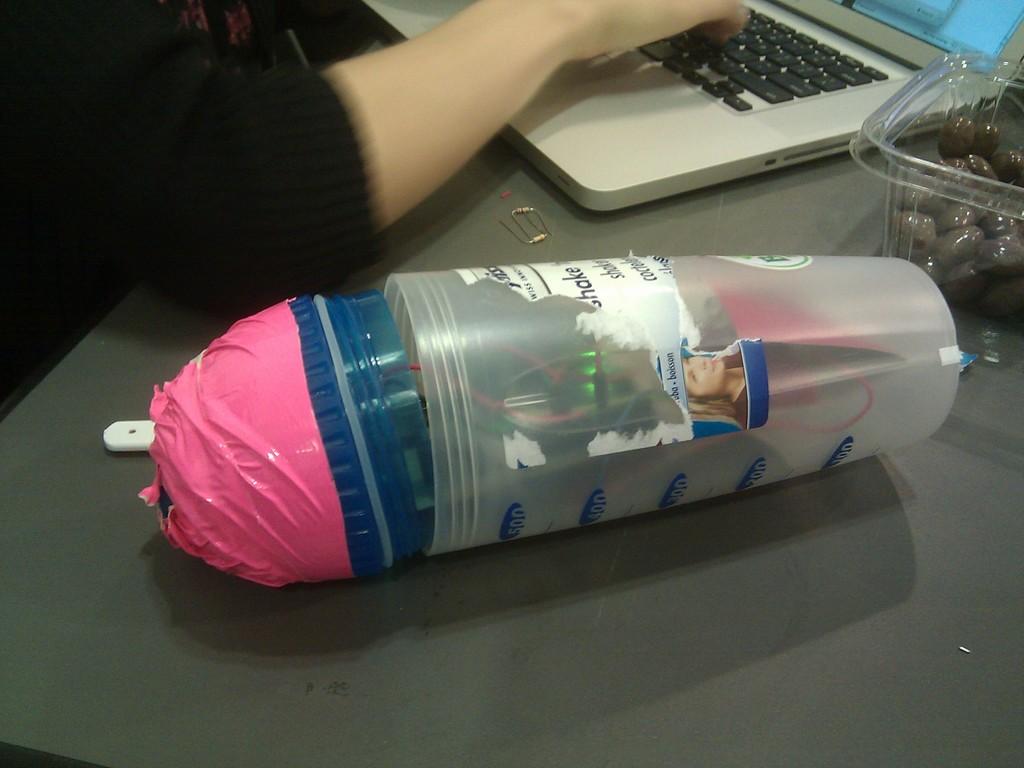Is the word shake on the sticker on the bottle?
Make the answer very short. Yes. 